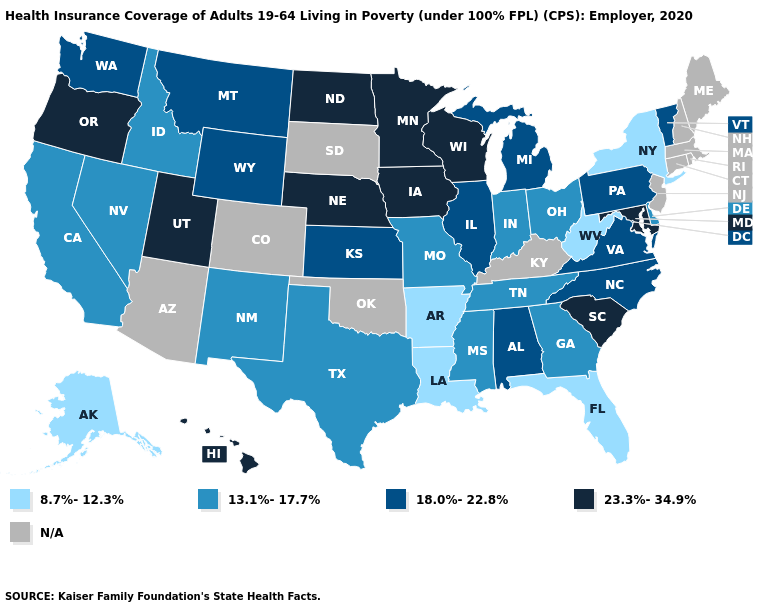What is the value of Virginia?
Concise answer only. 18.0%-22.8%. Among the states that border Alabama , does Florida have the lowest value?
Quick response, please. Yes. Which states hav the highest value in the West?
Concise answer only. Hawaii, Oregon, Utah. What is the value of Nebraska?
Short answer required. 23.3%-34.9%. What is the lowest value in the MidWest?
Quick response, please. 13.1%-17.7%. What is the value of South Carolina?
Be succinct. 23.3%-34.9%. What is the value of Alaska?
Give a very brief answer. 8.7%-12.3%. What is the value of Maryland?
Give a very brief answer. 23.3%-34.9%. What is the value of Florida?
Write a very short answer. 8.7%-12.3%. Does North Dakota have the lowest value in the USA?
Concise answer only. No. What is the highest value in the USA?
Short answer required. 23.3%-34.9%. How many symbols are there in the legend?
Give a very brief answer. 5. What is the highest value in the USA?
Give a very brief answer. 23.3%-34.9%. Which states hav the highest value in the Northeast?
Short answer required. Pennsylvania, Vermont. 